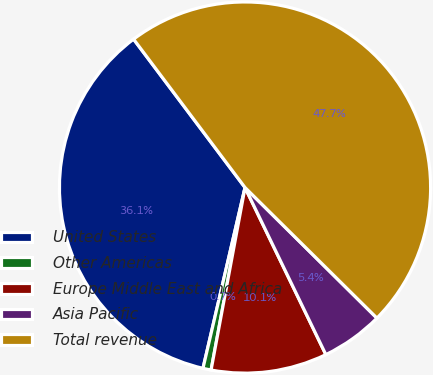<chart> <loc_0><loc_0><loc_500><loc_500><pie_chart><fcel>United States<fcel>Other Americas<fcel>Europe Middle East and Africa<fcel>Asia Pacific<fcel>Total revenue<nl><fcel>36.11%<fcel>0.71%<fcel>10.1%<fcel>5.41%<fcel>47.67%<nl></chart> 